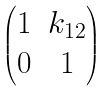<formula> <loc_0><loc_0><loc_500><loc_500>\begin{pmatrix} 1 & k _ { 1 2 } \\ 0 & 1 \end{pmatrix}</formula> 